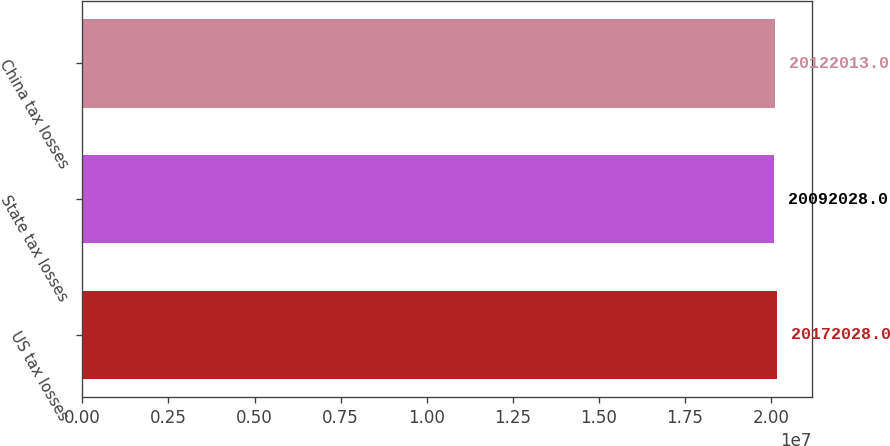<chart> <loc_0><loc_0><loc_500><loc_500><bar_chart><fcel>US tax losses<fcel>State tax losses<fcel>China tax losses<nl><fcel>2.0172e+07<fcel>2.0092e+07<fcel>2.0122e+07<nl></chart> 